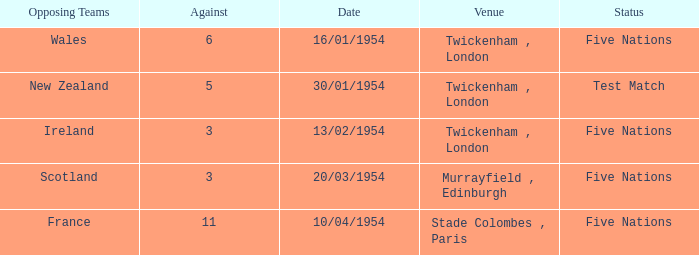What is the condition when the opposition is 11? Five Nations. 